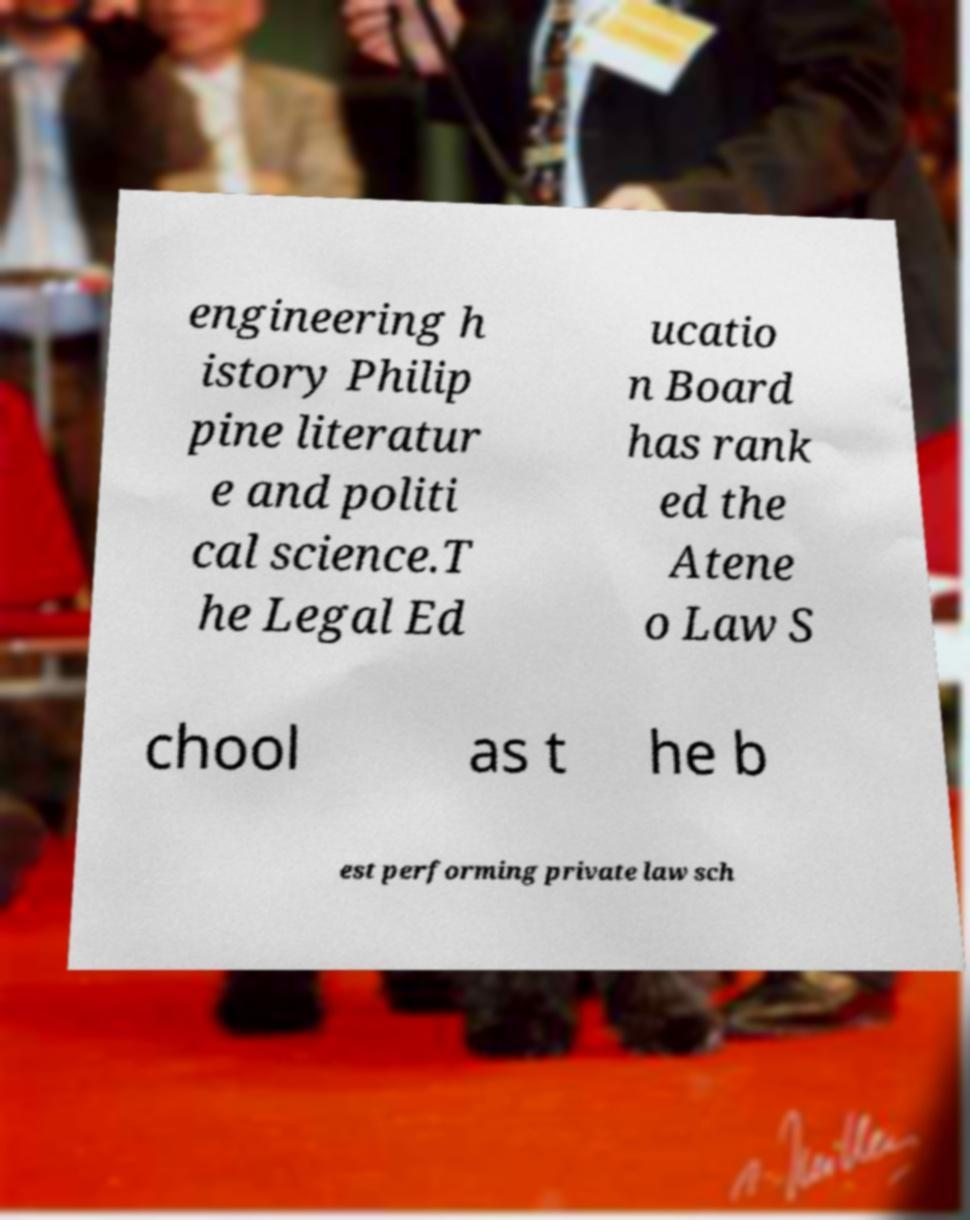Can you accurately transcribe the text from the provided image for me? engineering h istory Philip pine literatur e and politi cal science.T he Legal Ed ucatio n Board has rank ed the Atene o Law S chool as t he b est performing private law sch 